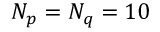Convert formula to latex. <formula><loc_0><loc_0><loc_500><loc_500>N _ { p } = N _ { q } = 1 0</formula> 